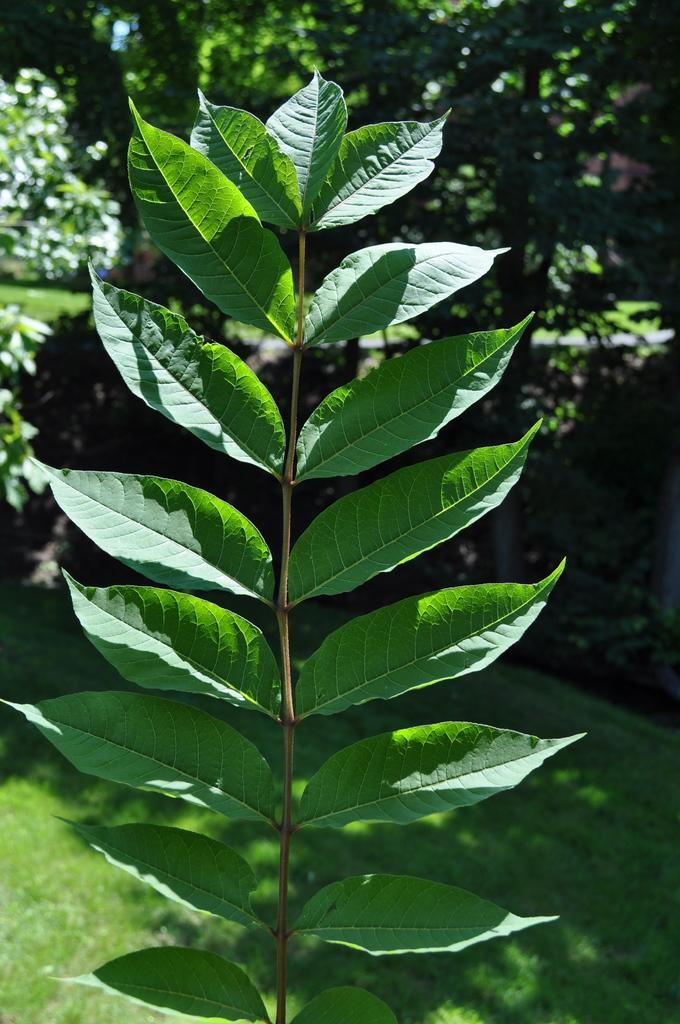What type of plant is depicted in the image? There is a stem with leaves in the image, which is identified as grass. What can be seen in the background of the image? There are trees in the background of the image. Can you tell me where the receipt is located in the image? There is no receipt present in the image. What type of toy can be seen in the image? There is no toy present in the image. 